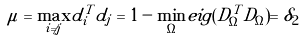<formula> <loc_0><loc_0><loc_500><loc_500>\mu = \underset { i \ne j } { \max } d _ { i } ^ { T } d _ { j } = 1 - \underset { \Omega } { \min } e i g ( D _ { \Omega } ^ { T } D _ { \Omega } ) = \delta _ { 2 }</formula> 